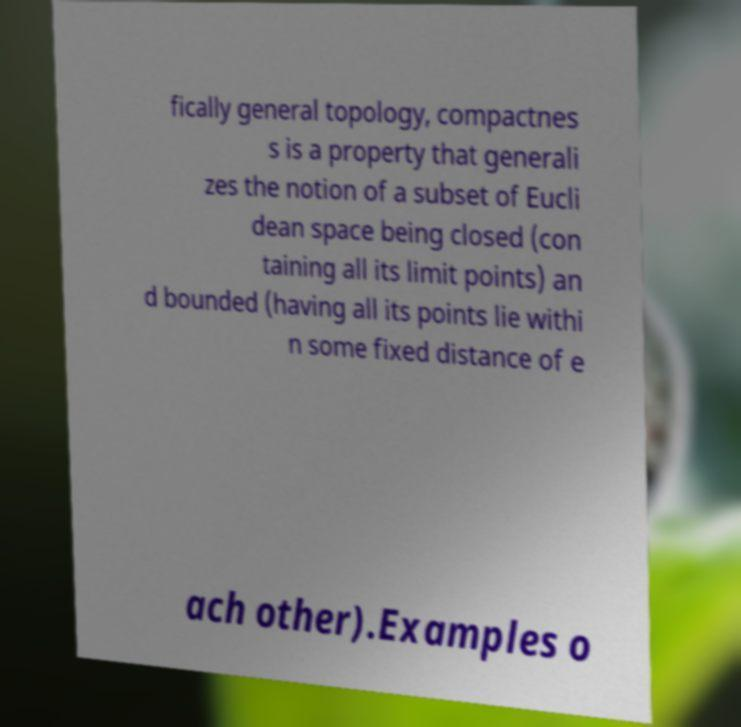Could you extract and type out the text from this image? fically general topology, compactnes s is a property that generali zes the notion of a subset of Eucli dean space being closed (con taining all its limit points) an d bounded (having all its points lie withi n some fixed distance of e ach other).Examples o 